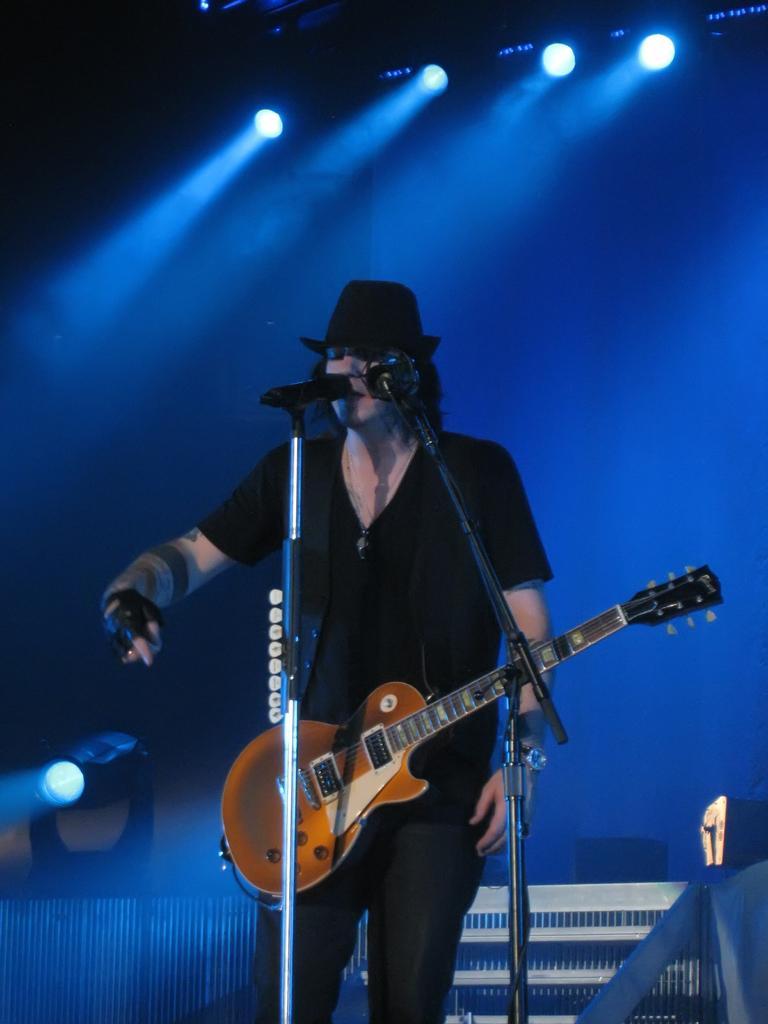Please provide a concise description of this image. In this image, we can see a person wearing a guitar and standing in front of the mic. There are lights at the top of the image. There is a musical equipment at the bottom of the image. There is an another light in the bottom left of the image. 